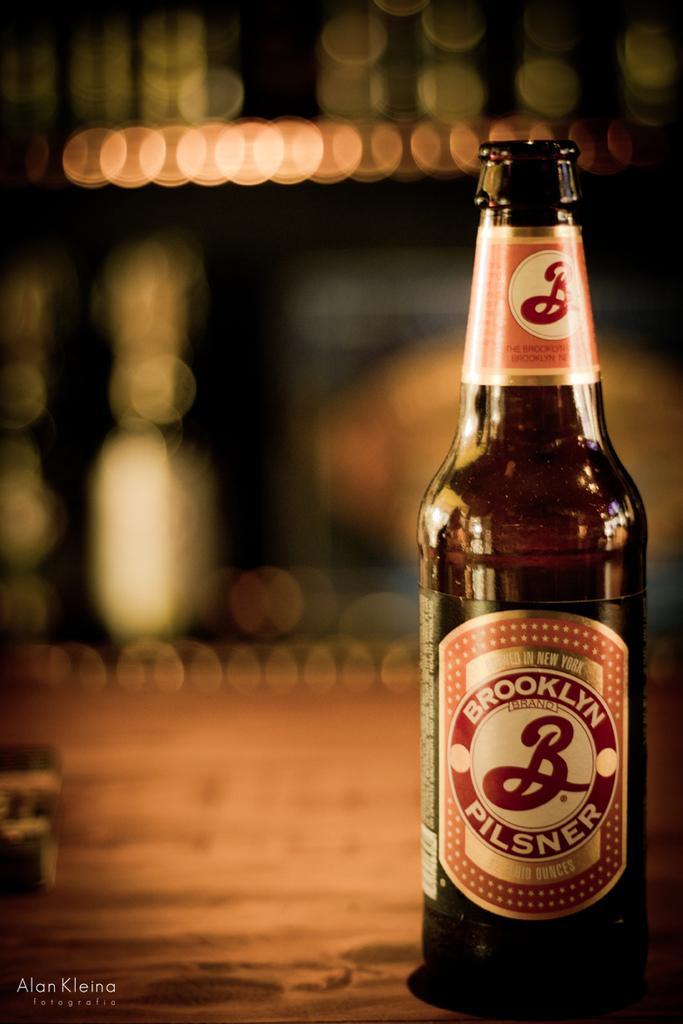Could you give a brief overview of what you see in this image? In the image we can see there is a wine bottle in front of the image and the background the image is blur. 